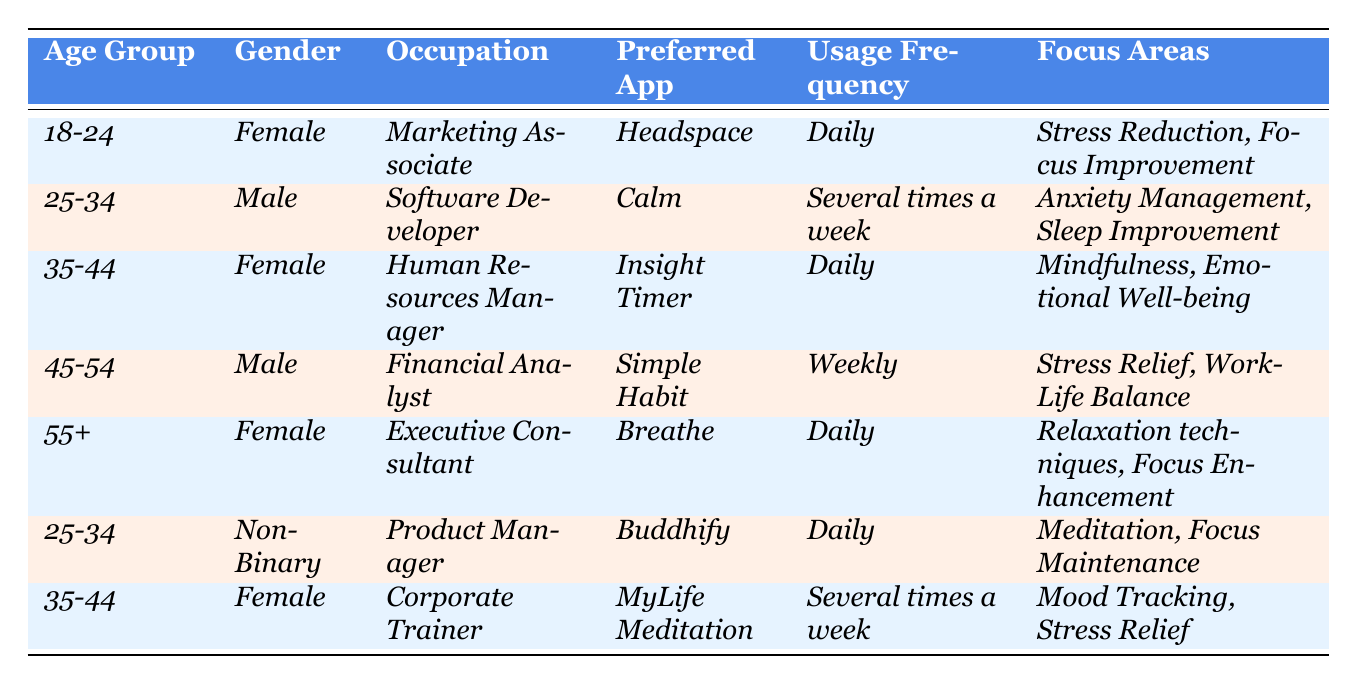What is the most preferred app among the users in the 18-24 age group? In the 18-24 age group, the preferred app listed is Headspace.
Answer: Headspace How many users are utilizing mental wellness apps daily? There are four users (three females and one non-binary) using mental wellness apps daily.
Answer: Four users What age group has the least instances of weekly app usage? The only user with weekly app usage is in the 45-54 age group, indicating that it's the least populated category for this frequency.
Answer: 45-54 age group Which gender has more representation among the users who prefer meditation-focused apps? Analyzing the table, the majority (three out of six users) who prefer meditation-focused apps are female, specifically those using Insight Timer and MyLife Meditation.
Answer: Female What are the focus areas of the user aged 55 and above? The focus areas for the user aged 55 and above are relaxation techniques and focus enhancement, specifically associated with the app Breathe.
Answer: Relaxation techniques, Focus Enhancement How many users in the 25-34 age group prefer daily usage of their mental wellness apps? There are two users in the 25-34 age group who prefer daily usage of their mental wellness apps; one is Non-Binary and uses Buddhify, and the other is Male and uses Calm.
Answer: Two users What is the average age of users listed in the table? The ages can be estimated by the midpoints of the age groups: (21 + 29.5 + 39.5 + 49.5 + 60)/5 = 39.5 years, estimating each group’s average for a total of 5 users.
Answer: 39.5 years Is there a user from a technical occupation who prefers a daily app? Yes, the user aged 25-34, who is a Software Developer, uses Calm several times a week and does not prefer daily usage, therefore contradicting the statement.
Answer: No Which age group has the highest number of users mentioning stress relief as a focus area? Stress relief is mentioned by users from the 35-44 and 45-54 age groups, indicating these two groups have the highest focus on this area.
Answer: 35-44 and 45-54 age groups Identify the user with the highest frequency of app usage. The users who reported daily app usage are 18-24 (Headspace), 35-44 (Insight Timer), 55+ (Breathe), and 25-34 (Buddhify), making them the highest frequency users.
Answer: 18-24, 35-44, 55+, 25-34 age groups 